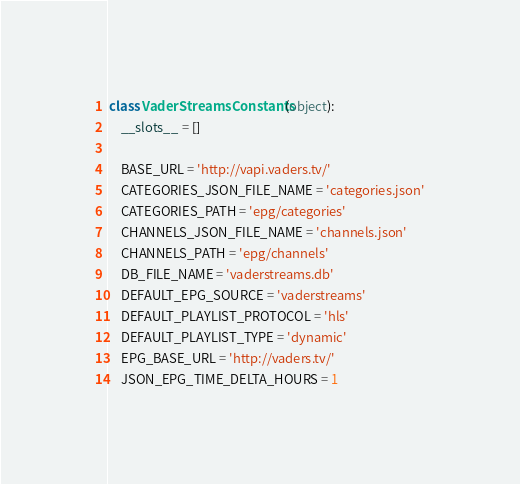Convert code to text. <code><loc_0><loc_0><loc_500><loc_500><_Python_>class VaderStreamsConstants(object):
    __slots__ = []

    BASE_URL = 'http://vapi.vaders.tv/'
    CATEGORIES_JSON_FILE_NAME = 'categories.json'
    CATEGORIES_PATH = 'epg/categories'
    CHANNELS_JSON_FILE_NAME = 'channels.json'
    CHANNELS_PATH = 'epg/channels'
    DB_FILE_NAME = 'vaderstreams.db'
    DEFAULT_EPG_SOURCE = 'vaderstreams'
    DEFAULT_PLAYLIST_PROTOCOL = 'hls'
    DEFAULT_PLAYLIST_TYPE = 'dynamic'
    EPG_BASE_URL = 'http://vaders.tv/'
    JSON_EPG_TIME_DELTA_HOURS = 1</code> 